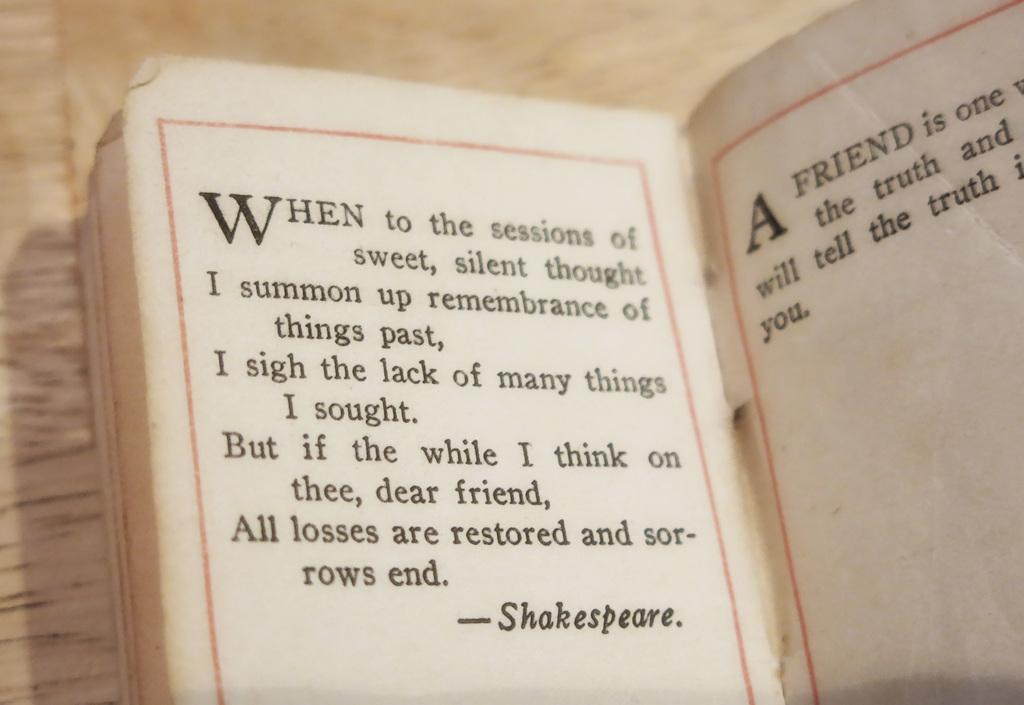<image>
Give a short and clear explanation of the subsequent image. a quote in a book that is from Shakespeare 